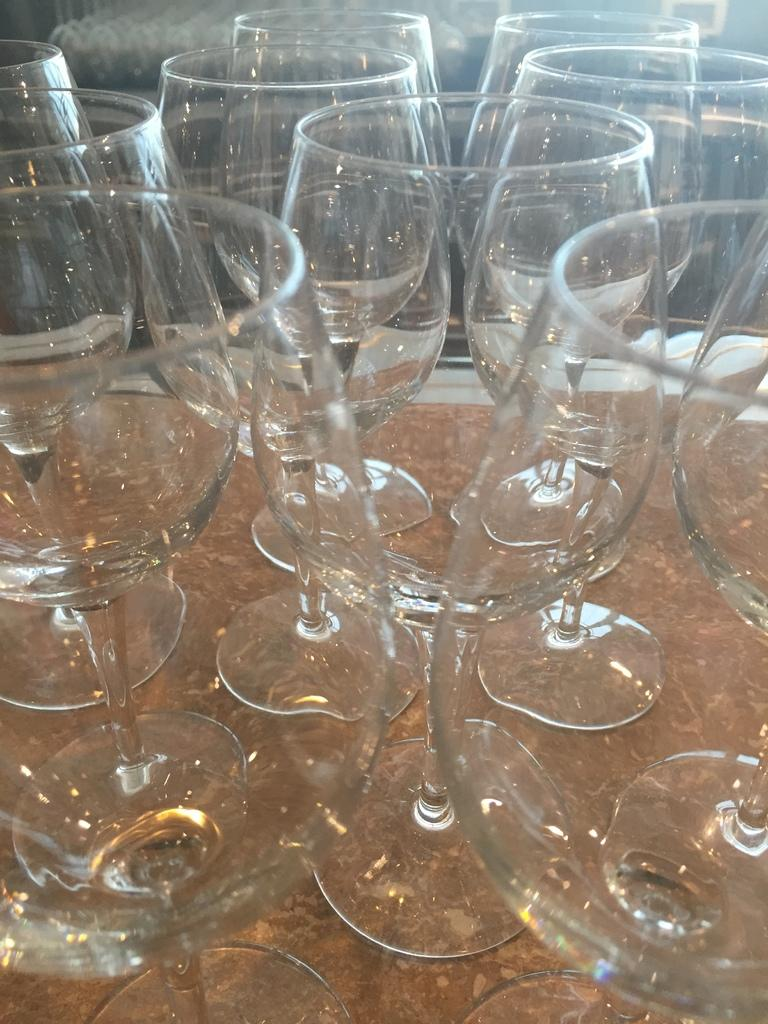What objects are present in the image? There are glasses in the image. What is the condition of the glasses? The glasses are empty. On what surface are the glasses placed? The glasses are placed on a brown surface. What type of power can be seen coming from the volcano in the image? There is no volcano present in the image, so it is not possible to determine what type of power might be coming from it. 